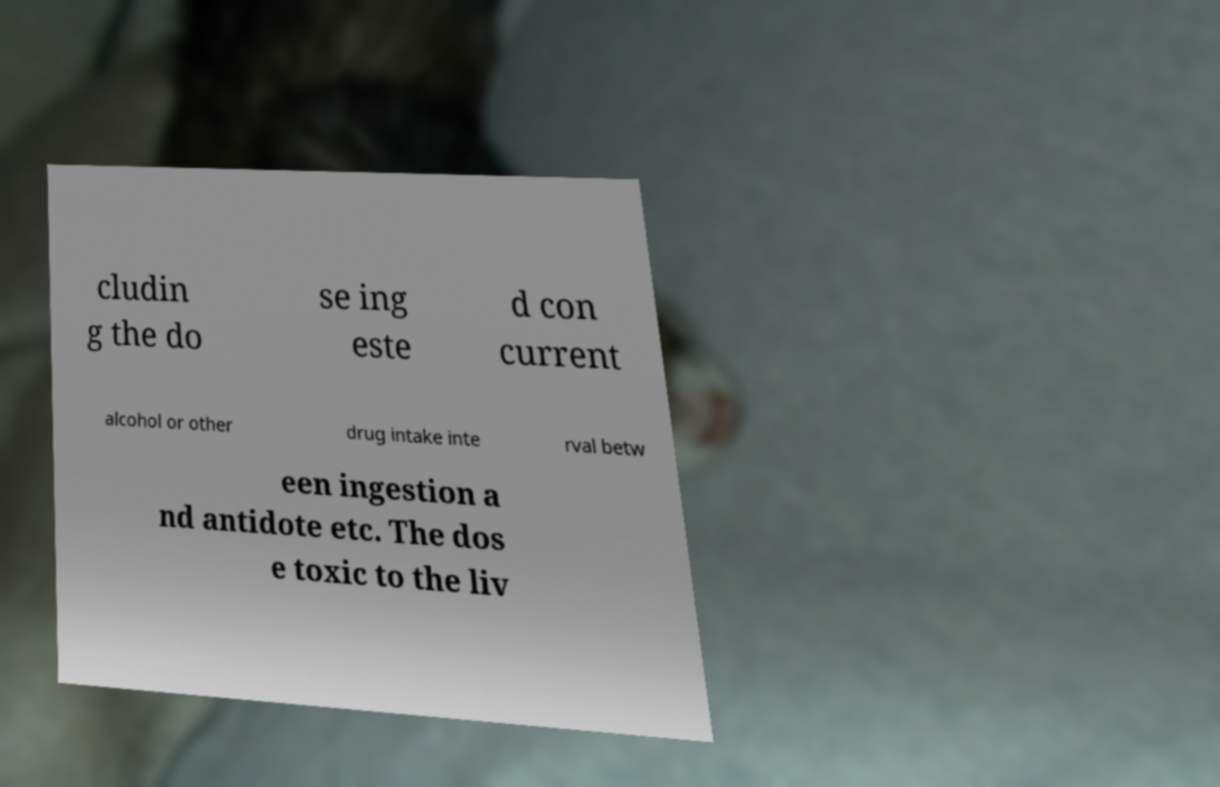Please identify and transcribe the text found in this image. cludin g the do se ing este d con current alcohol or other drug intake inte rval betw een ingestion a nd antidote etc. The dos e toxic to the liv 